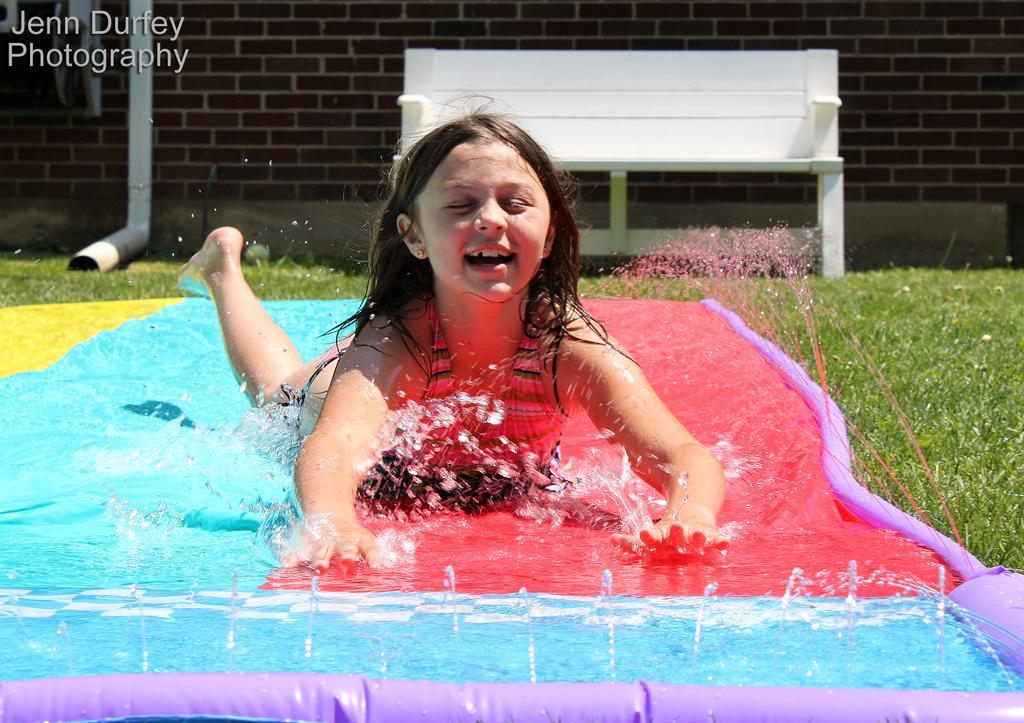In one or two sentences, can you explain what this image depicts? In the picture I can see a girl is lying on an object. In the background I can see the water, grass, a brick wall, white color object and some other things. On the top left side of the image I can see a watermark. 